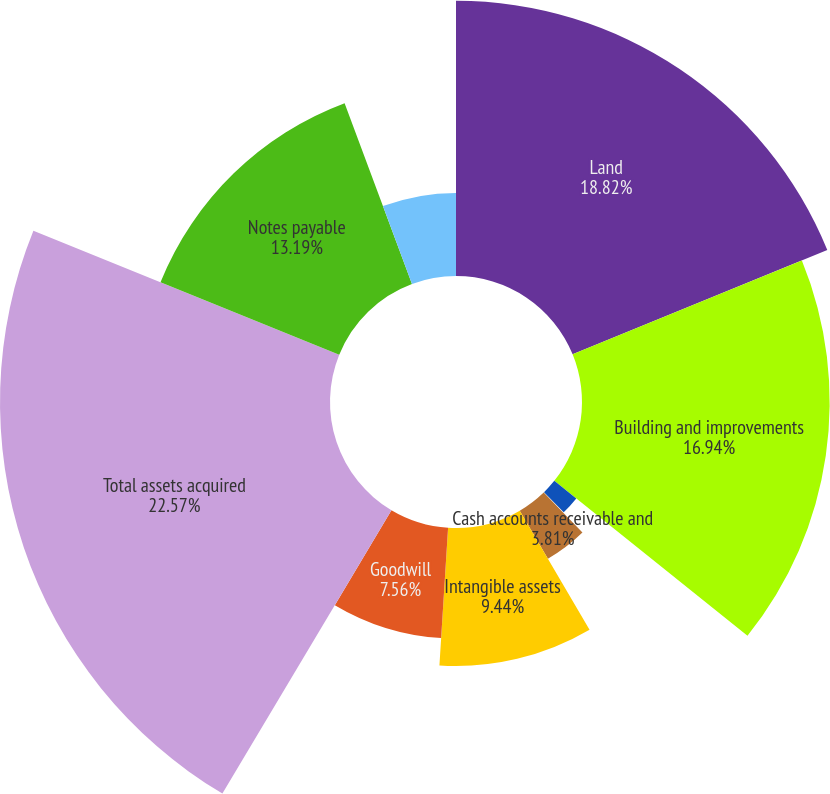<chart> <loc_0><loc_0><loc_500><loc_500><pie_chart><fcel>Land<fcel>Building and improvements<fcel>Construction in progress<fcel>Investments in unconsolidated<fcel>Cash accounts receivable and<fcel>Intangible assets<fcel>Goodwill<fcel>Total assets acquired<fcel>Notes payable<fcel>Accounts payable accrued<nl><fcel>18.82%<fcel>16.94%<fcel>1.93%<fcel>0.06%<fcel>3.81%<fcel>9.44%<fcel>7.56%<fcel>22.57%<fcel>13.19%<fcel>5.68%<nl></chart> 